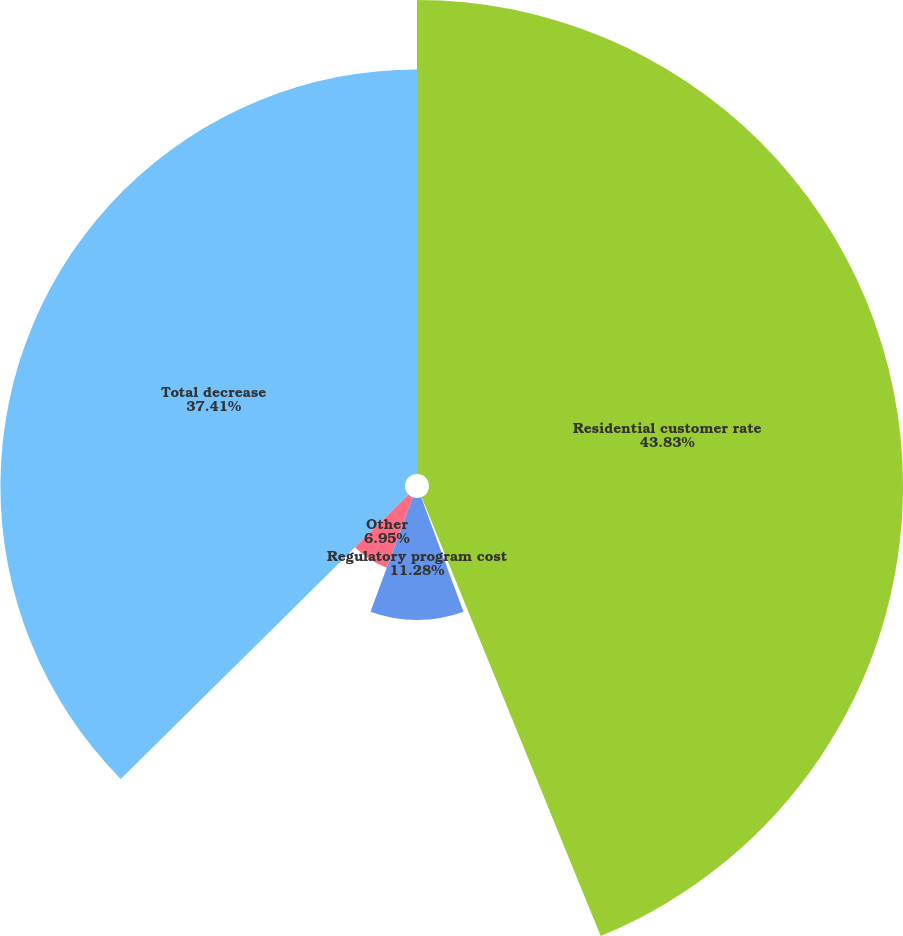<chart> <loc_0><loc_0><loc_500><loc_500><pie_chart><fcel>Residential customer rate<fcel>Commodity margin<fcel>Regulatory program cost<fcel>Other<fcel>Total decrease<nl><fcel>43.83%<fcel>0.53%<fcel>11.28%<fcel>6.95%<fcel>37.41%<nl></chart> 